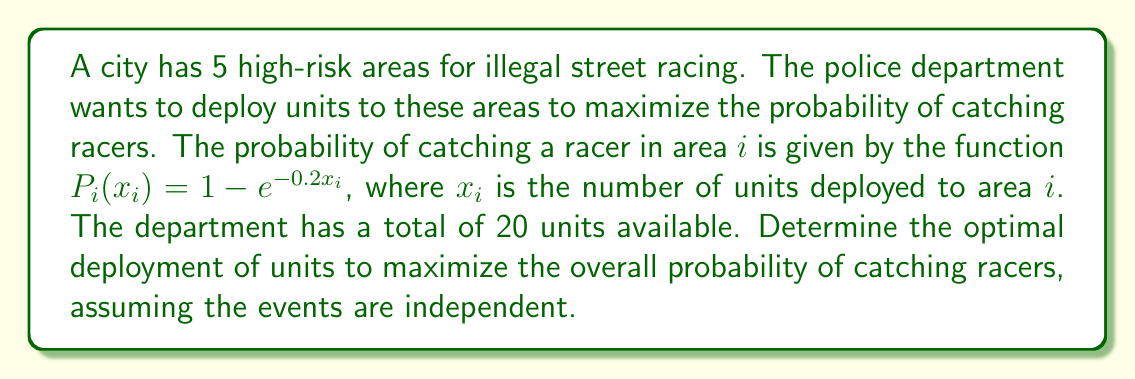Solve this math problem. 1) Let's define our objective function. Since the events are independent, the overall probability of catching at least one racer is:

   $$P_{total} = 1 - \prod_{i=1}^5 (1 - P_i(x_i)) = 1 - \prod_{i=1}^5 e^{-0.2x_i}$$

2) Our optimization problem is:

   Maximize: $$P_{total} = 1 - e^{-0.2(x_1 + x_2 + x_3 + x_4 + x_5)}$$
   Subject to: $$\sum_{i=1}^5 x_i = 20$$ and $$x_i \geq 0$$ for all $i$

3) This is a nonlinear optimization problem with equality constraint. We can use the method of Lagrange multipliers.

4) The Lagrangian function is:

   $$L(x_1, x_2, x_3, x_4, x_5, \lambda) = 1 - e^{-0.2(x_1 + x_2 + x_3 + x_4 + x_5)} + \lambda(20 - x_1 - x_2 - x_3 - x_4 - x_5)$$

5) Taking partial derivatives and setting them to zero:

   $$\frac{\partial L}{\partial x_i} = 0.2e^{-0.2(x_1 + x_2 + x_3 + x_4 + x_5)} - \lambda = 0$$ for all $i$
   $$\frac{\partial L}{\partial \lambda} = 20 - x_1 - x_2 - x_3 - x_4 - x_5 = 0$$

6) From the first equation, we can see that all $x_i$ must be equal. Let's call this common value $x$.

7) From the second equation: $5x = 20$

8) Therefore, the optimal solution is to distribute the units equally among all areas:
   $$x_1 = x_2 = x_3 = x_4 = x_5 = 4$$
Answer: Deploy 4 units to each of the 5 areas. 